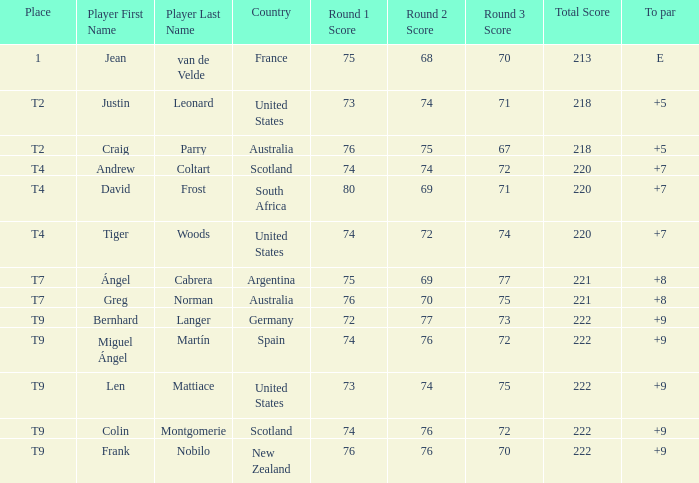For the match in which player David Frost scored a To Par of +7, what was the final score? 80-69-71=220. 